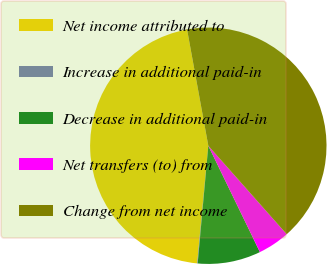Convert chart to OTSL. <chart><loc_0><loc_0><loc_500><loc_500><pie_chart><fcel>Net income attributed to<fcel>Increase in additional paid-in<fcel>Decrease in additional paid-in<fcel>Net transfers (to) from<fcel>Change from net income<nl><fcel>45.62%<fcel>0.07%<fcel>8.63%<fcel>4.35%<fcel>41.34%<nl></chart> 